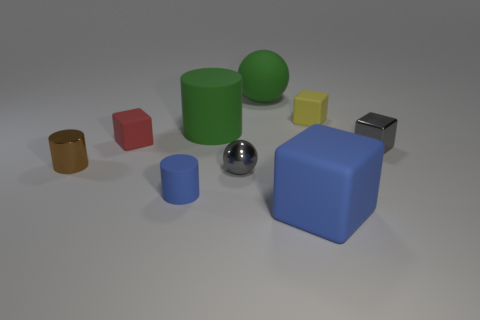Add 1 brown shiny cylinders. How many objects exist? 10 Subtract all cubes. How many objects are left? 5 Subtract all big green spheres. Subtract all big blue rubber cubes. How many objects are left? 7 Add 5 big green matte things. How many big green matte things are left? 7 Add 4 blue matte cylinders. How many blue matte cylinders exist? 5 Subtract 1 blue blocks. How many objects are left? 8 